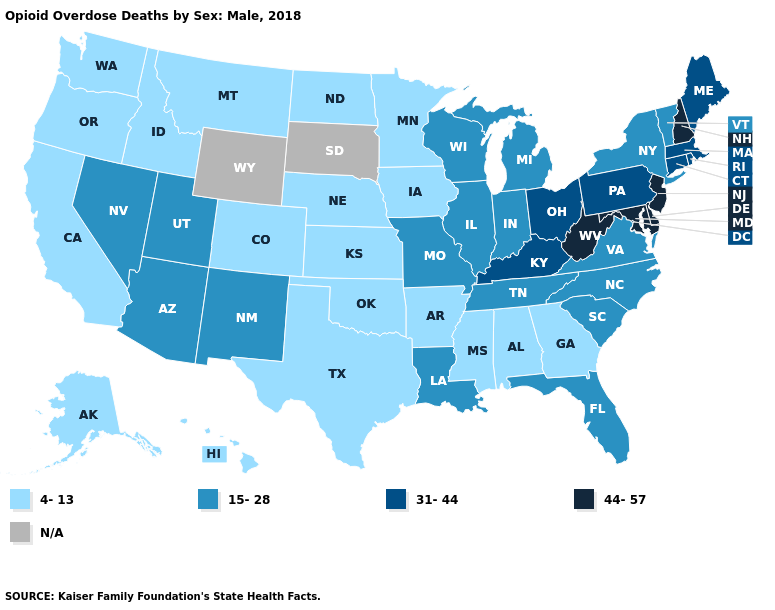What is the value of Idaho?
Answer briefly. 4-13. What is the highest value in the USA?
Write a very short answer. 44-57. What is the lowest value in the USA?
Write a very short answer. 4-13. Does Oklahoma have the lowest value in the South?
Keep it brief. Yes. Which states have the highest value in the USA?
Write a very short answer. Delaware, Maryland, New Hampshire, New Jersey, West Virginia. Does Delaware have the lowest value in the USA?
Quick response, please. No. Which states have the lowest value in the USA?
Concise answer only. Alabama, Alaska, Arkansas, California, Colorado, Georgia, Hawaii, Idaho, Iowa, Kansas, Minnesota, Mississippi, Montana, Nebraska, North Dakota, Oklahoma, Oregon, Texas, Washington. Does the first symbol in the legend represent the smallest category?
Keep it brief. Yes. Which states hav the highest value in the West?
Short answer required. Arizona, Nevada, New Mexico, Utah. Which states have the highest value in the USA?
Keep it brief. Delaware, Maryland, New Hampshire, New Jersey, West Virginia. What is the lowest value in the MidWest?
Quick response, please. 4-13. Among the states that border Utah , which have the lowest value?
Short answer required. Colorado, Idaho. Name the states that have a value in the range 31-44?
Answer briefly. Connecticut, Kentucky, Maine, Massachusetts, Ohio, Pennsylvania, Rhode Island. 